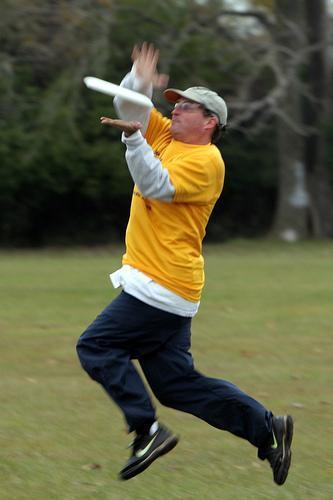How many people are in the photo?
Give a very brief answer. 1. 